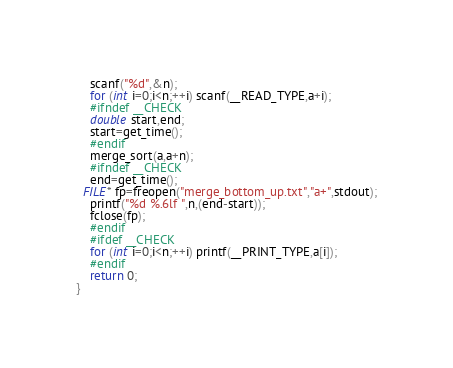Convert code to text. <code><loc_0><loc_0><loc_500><loc_500><_C_>	scanf("%d",&n);
	for (int i=0;i<n;++i) scanf(__READ_TYPE,a+i);
	#ifndef __CHECK
	double start,end;
	start=get_time();
	#endif
	merge_sort(a,a+n);
	#ifndef __CHECK
	end=get_time();
  FILE* fp=freopen("merge_bottom_up.txt","a+",stdout);
	printf("%d %.6lf ",n,(end-start));
	fclose(fp);
	#endif
	#ifdef __CHECK
	for (int i=0;i<n;++i) printf(__PRINT_TYPE,a[i]);
	#endif
	return 0;
}
</code> 